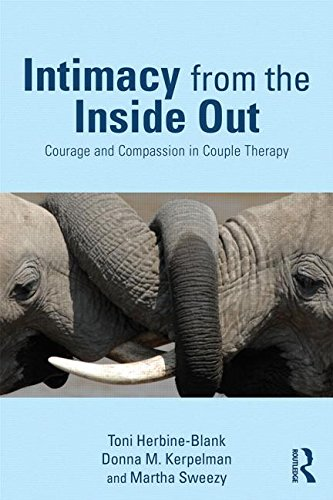How might the principles in this book apply to non-romantic relationships? The principles in 'Intimacy from the Inside Out' can also enhance non-romantic relationships by improving emotional understanding and communication, essential for any deep and lasting relationship. 